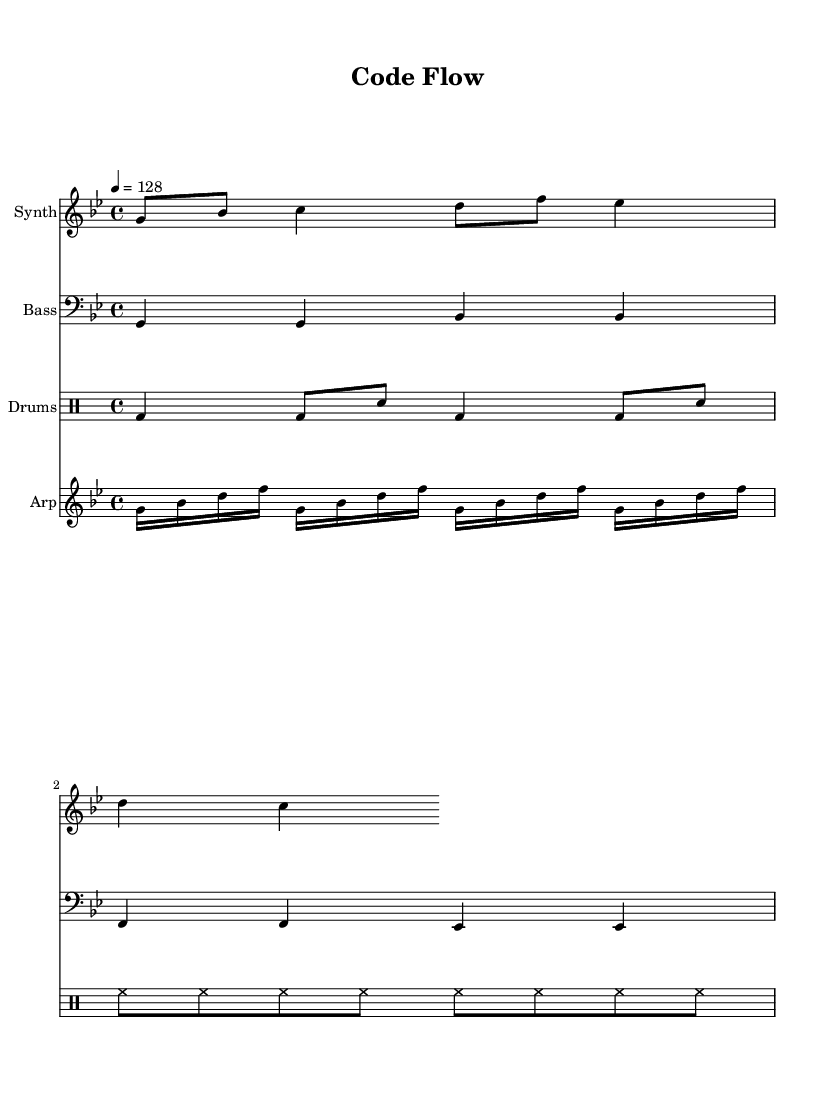What is the key signature of this music? The key signature can be determined by looking at the beginning of the sheet music, where the key is indicated. This music is in the key of G minor, which has two flats (B flat and E flat).
Answer: G minor What is the time signature of this music? The time signature is found at the beginning of the score, indicating how many beats are in each measure. Here, the time signature is 4/4, which means there are four beats per measure.
Answer: 4/4 What is the tempo marking of this piece? The tempo is indicated by a number placed above the staff. In this case, the marking shows 4 = 128, meaning there are 128 beats per minute.
Answer: 128 How many measures are present in the melody? To determine the number of measures, one can count the bar lines in the melody section. The melody contains four measures since it has four sets of bar lines.
Answer: 4 What type of rhythm is predominantly used in the arpeggiator part? The rhythm in the arpeggiator part can be identified by examining the note values. It consistently uses sixteenth notes in a repeating pattern, which gives it a fast-paced feel typical of dance music.
Answer: Sixteenth notes What is the style of the drum part in this piece? By analyzing the drum part shown, it consists of kick drum (bd), snare (sn), and hi-hats (hh), which are common elements in electronic dance music. The pattern and energy indicate it's styled for upbeat dancing.
Answer: Upbeat electronic dance style What instruments are featured in this score? The instruments can be individually identified in the score, where there are four different staffs: "Synth," "Bass," "Drums," and "Arp." This indicates a combination of synthesized sounds and traditional rhythmic elements.
Answer: Synth, Bass, Drums, Arp 